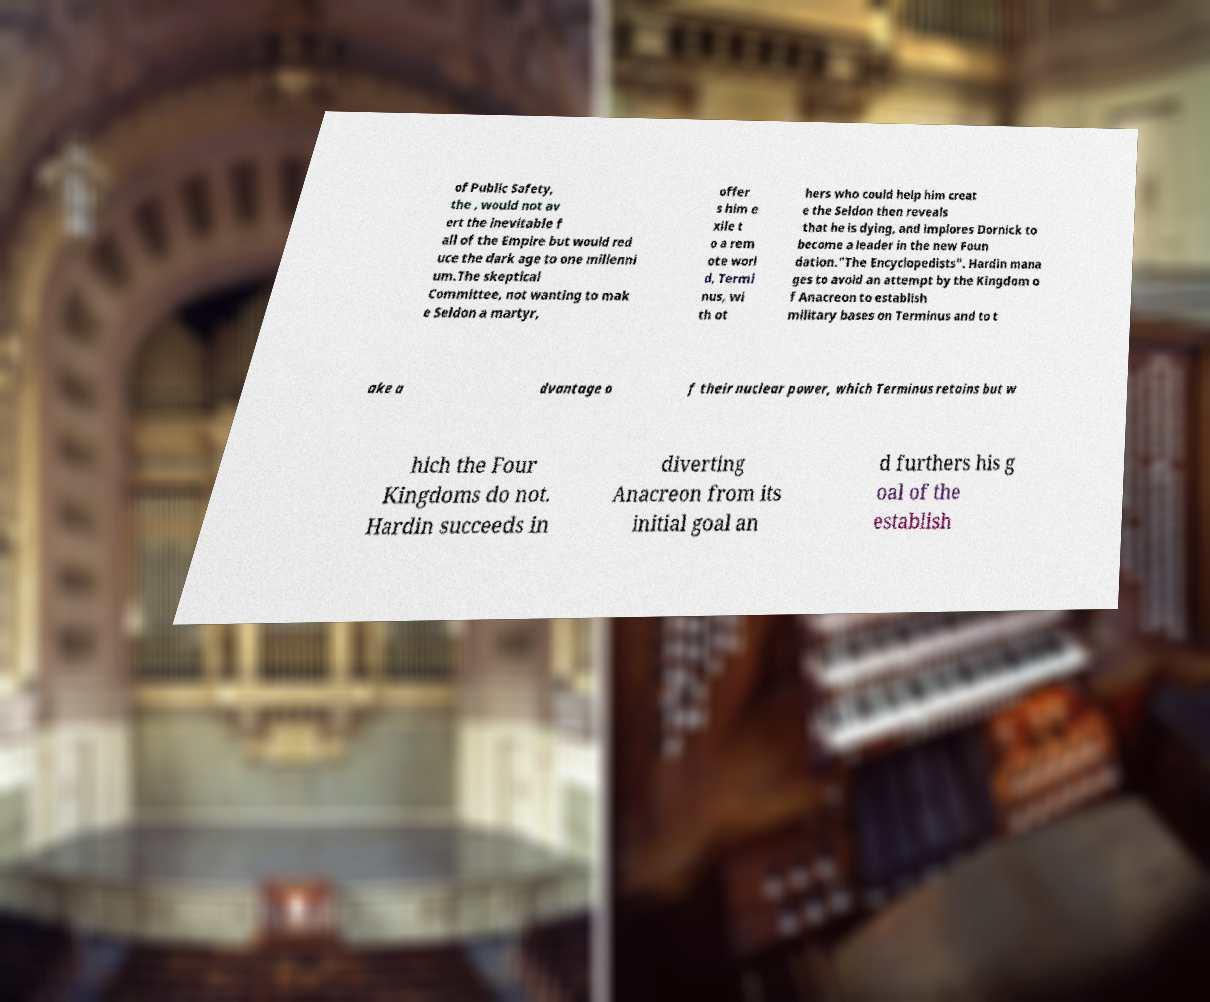Can you accurately transcribe the text from the provided image for me? of Public Safety, the , would not av ert the inevitable f all of the Empire but would red uce the dark age to one millenni um.The skeptical Committee, not wanting to mak e Seldon a martyr, offer s him e xile t o a rem ote worl d, Termi nus, wi th ot hers who could help him creat e the Seldon then reveals that he is dying, and implores Dornick to become a leader in the new Foun dation."The Encyclopedists". Hardin mana ges to avoid an attempt by the Kingdom o f Anacreon to establish military bases on Terminus and to t ake a dvantage o f their nuclear power, which Terminus retains but w hich the Four Kingdoms do not. Hardin succeeds in diverting Anacreon from its initial goal an d furthers his g oal of the establish 